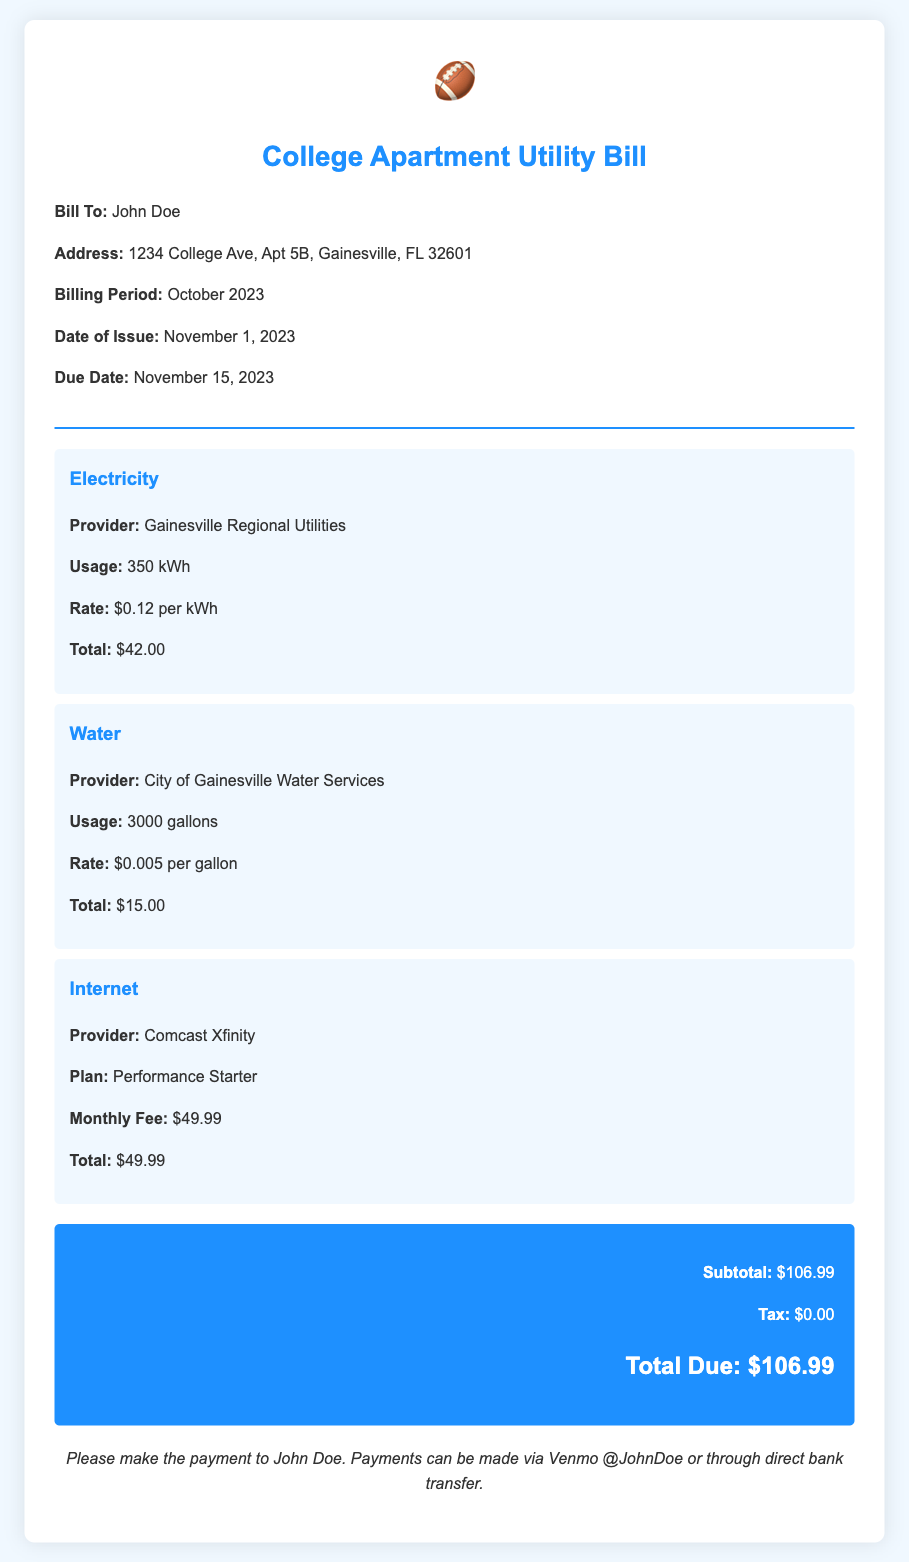What is the billing period? The billing period is mentioned in the document, which states it is for October 2023.
Answer: October 2023 Who is the bill issued to? The document specifies the name of the person the bill is issued to, which is John Doe.
Answer: John Doe What is the total due amount? The total due amount is calculated and mentioned in the document as $106.99.
Answer: $106.99 What is the usage in kilowatt-hours for electricity? The document lists the electricity usage as 350 kWh.
Answer: 350 kWh What is the provider for water services? The document specifies that the water services provider is the City of Gainesville Water Services.
Answer: City of Gainesville Water Services How much is the monthly fee for internet? The document states the monthly fee for internet is $49.99.
Answer: $49.99 When is the due date for the bill? The due date for the bill is provided in the document as November 15, 2023.
Answer: November 15, 2023 What is the total charge for water? The document provides the total charge for water as $15.00.
Answer: $15.00 What payment method is mentioned for settling the bill? The document specifies that payments can be made via Venmo or bank transfer.
Answer: Venmo or bank transfer 